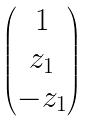<formula> <loc_0><loc_0><loc_500><loc_500>\begin{pmatrix} 1 \\ z _ { 1 } \\ - z _ { 1 } \end{pmatrix}</formula> 